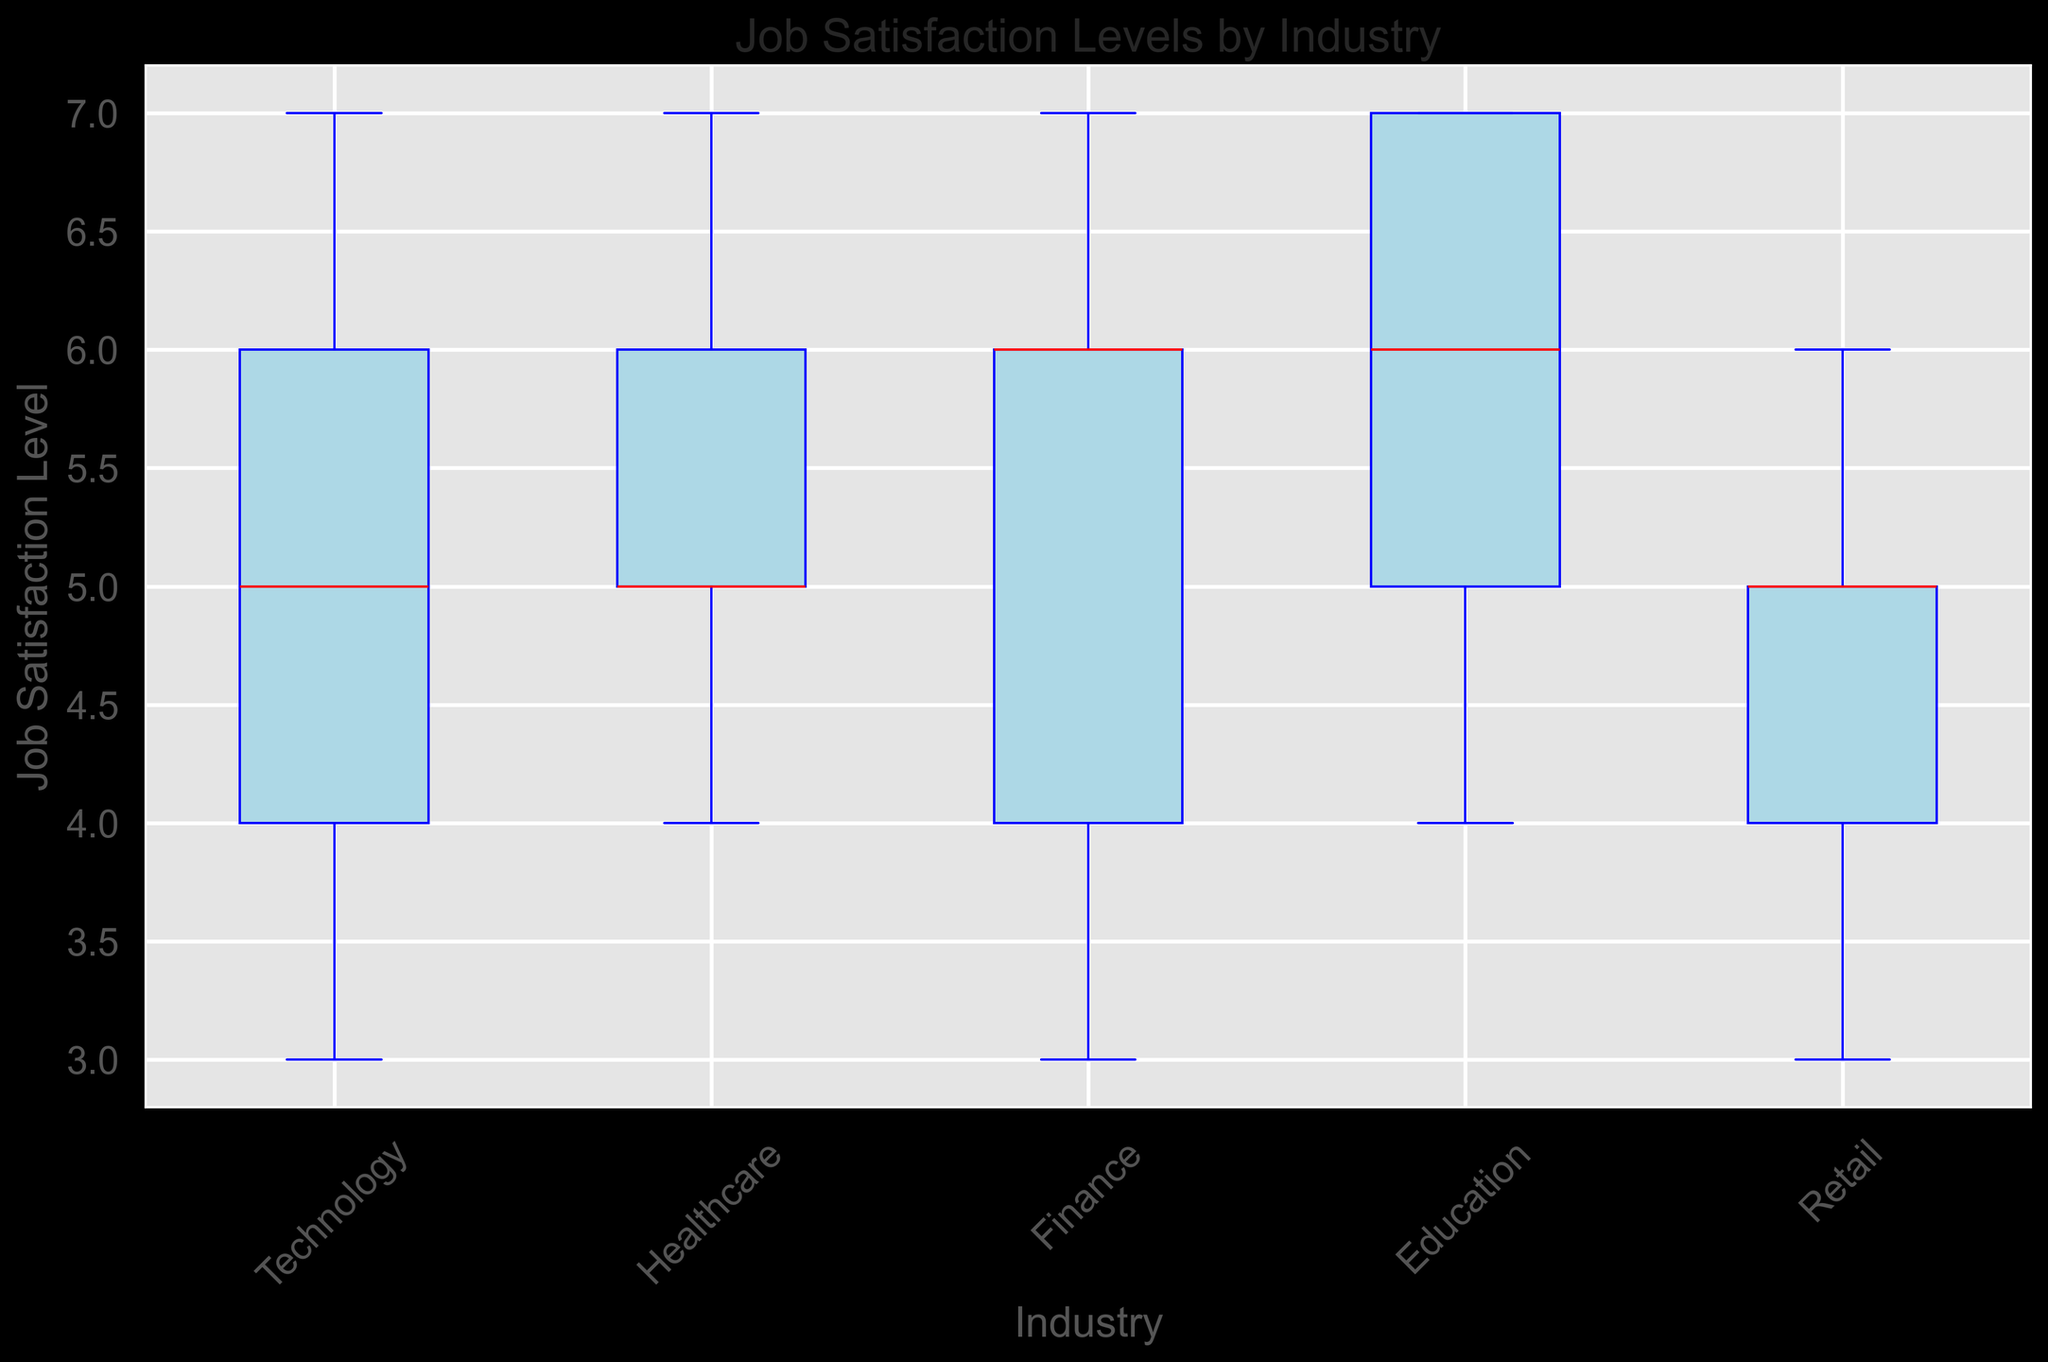1. Which industry shows the highest median job satisfaction level? By observing the red lines in each box, which represent the medians, you can see that the median line in the Education box is the highest.
Answer: Education 2. Which industry has the largest range in job satisfaction levels? The range is determined by the length of the box and the whiskers. By visually comparing the boxes and whiskers of each industry, one can see that the Technology industry has the largest spread.
Answer: Technology 3. Are there any industries where the job satisfaction levels do not vary significantly? If the box and whiskers are short, it means there's little variation. Here, Retail has the smallest range and variance in job satisfaction levels.
Answer: Retail 4. Do any industries exhibit outliers in job satisfaction levels? Outliers are shown as distinct points outside the whiskers. None of the industries show visible outliers in this box plot.
Answer: None 5. Compare the median job satisfaction levels between Healthcare and Finance industries. Which is higher? By comparing the red median lines directly, we can see that the Healthcare industry's median is the same as Finance's median. However, the height in the Healthcare box appears slightly higher.
Answer: Healthcare 6. What's the median job satisfaction level for Finance compared to Retail? Compare the red median lines in the boxes for Finance and Retail. The median for Finance is higher than Retail.
Answer: Finance 7. Which industry has the highest upper quartile in job satisfaction levels? The upper quartile is the top edge of the box. Comparing the boxes, Education has the highest upper quartile line.
Answer: Education 8. Are there any industries where the job satisfaction levels are consistently high (i.e., the lower whisker is higher than the lower quartile of other industries)? By observing the lowest points of the whiskers, Education is the industry where even the lower whisker is relatively higher compared to the lower quartiles of most other industries.
Answer: Education 9. How does the job satisfaction variability in Healthcare compare to that in Technology? By looking at the length of the boxes and whiskers for Healthcare and Technology, we see that Technology has a larger range, indicating higher variability.
Answer: Healthcare has less variability 10. Which industry's job satisfaction levels have the least interquartile range (IQR)? The IQR is represented by the height of the box. Retail has the shortest box, indicating the smallest IQR.
Answer: Retail 